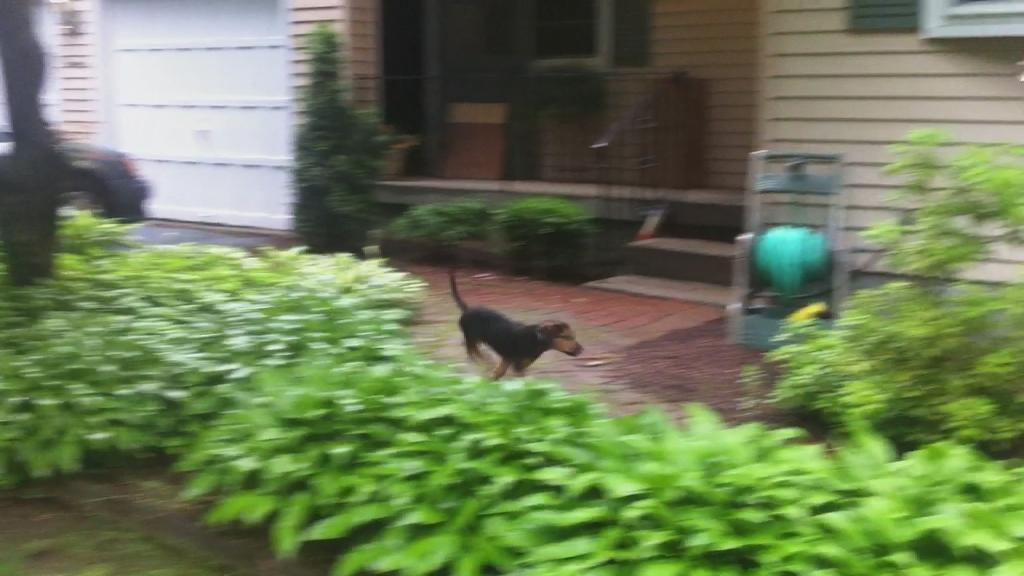What type of living organisms can be seen in the image? Plants are visible in the image. What animal is present in the image? There is a dog in the image. What can be seen in the background of the image? There is a building and stairs visible in the background of the image. Can you see a monkey playing with a nail on the attraction in the image? There is no monkey, nail, or attraction present in the image. 